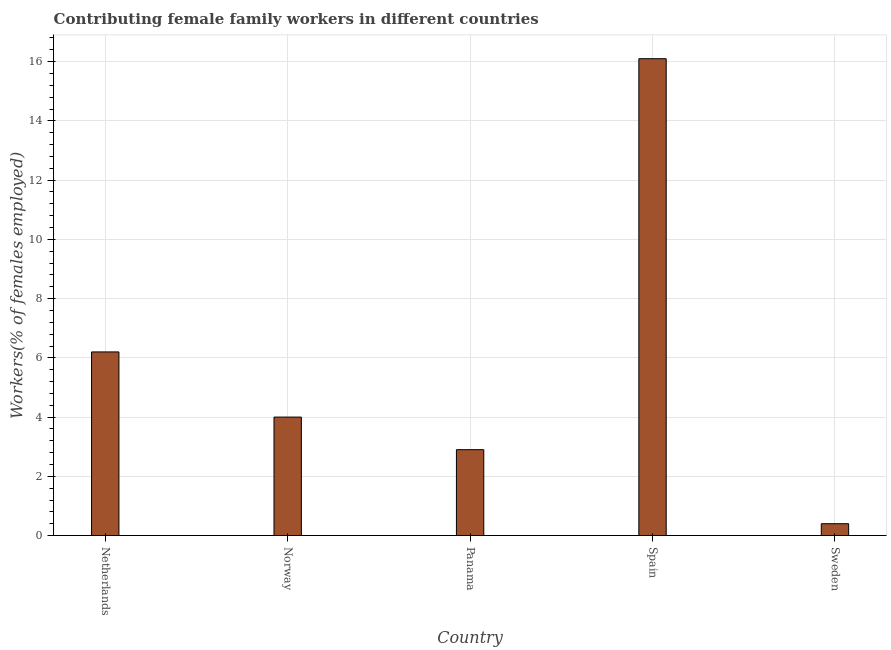Does the graph contain any zero values?
Give a very brief answer. No. What is the title of the graph?
Offer a very short reply. Contributing female family workers in different countries. What is the label or title of the Y-axis?
Make the answer very short. Workers(% of females employed). What is the contributing female family workers in Panama?
Make the answer very short. 2.9. Across all countries, what is the maximum contributing female family workers?
Provide a succinct answer. 16.1. Across all countries, what is the minimum contributing female family workers?
Provide a succinct answer. 0.4. In which country was the contributing female family workers minimum?
Provide a short and direct response. Sweden. What is the sum of the contributing female family workers?
Keep it short and to the point. 29.6. What is the difference between the contributing female family workers in Netherlands and Spain?
Give a very brief answer. -9.9. What is the average contributing female family workers per country?
Provide a short and direct response. 5.92. What is the median contributing female family workers?
Ensure brevity in your answer.  4. Is the contributing female family workers in Panama less than that in Sweden?
Offer a very short reply. No. Is the difference between the contributing female family workers in Netherlands and Panama greater than the difference between any two countries?
Keep it short and to the point. No. What is the difference between the highest and the second highest contributing female family workers?
Keep it short and to the point. 9.9. Is the sum of the contributing female family workers in Panama and Spain greater than the maximum contributing female family workers across all countries?
Your answer should be compact. Yes. What is the difference between the highest and the lowest contributing female family workers?
Make the answer very short. 15.7. Are the values on the major ticks of Y-axis written in scientific E-notation?
Make the answer very short. No. What is the Workers(% of females employed) in Netherlands?
Make the answer very short. 6.2. What is the Workers(% of females employed) of Norway?
Provide a short and direct response. 4. What is the Workers(% of females employed) of Panama?
Ensure brevity in your answer.  2.9. What is the Workers(% of females employed) of Spain?
Keep it short and to the point. 16.1. What is the Workers(% of females employed) in Sweden?
Offer a terse response. 0.4. What is the difference between the Workers(% of females employed) in Netherlands and Norway?
Your answer should be very brief. 2.2. What is the difference between the Workers(% of females employed) in Netherlands and Panama?
Your answer should be very brief. 3.3. What is the difference between the Workers(% of females employed) in Netherlands and Spain?
Offer a very short reply. -9.9. What is the difference between the Workers(% of females employed) in Norway and Sweden?
Ensure brevity in your answer.  3.6. What is the difference between the Workers(% of females employed) in Panama and Spain?
Your answer should be compact. -13.2. What is the difference between the Workers(% of females employed) in Panama and Sweden?
Offer a terse response. 2.5. What is the ratio of the Workers(% of females employed) in Netherlands to that in Norway?
Provide a short and direct response. 1.55. What is the ratio of the Workers(% of females employed) in Netherlands to that in Panama?
Keep it short and to the point. 2.14. What is the ratio of the Workers(% of females employed) in Netherlands to that in Spain?
Your response must be concise. 0.39. What is the ratio of the Workers(% of females employed) in Norway to that in Panama?
Offer a terse response. 1.38. What is the ratio of the Workers(% of females employed) in Norway to that in Spain?
Provide a succinct answer. 0.25. What is the ratio of the Workers(% of females employed) in Panama to that in Spain?
Give a very brief answer. 0.18. What is the ratio of the Workers(% of females employed) in Panama to that in Sweden?
Make the answer very short. 7.25. What is the ratio of the Workers(% of females employed) in Spain to that in Sweden?
Offer a very short reply. 40.25. 